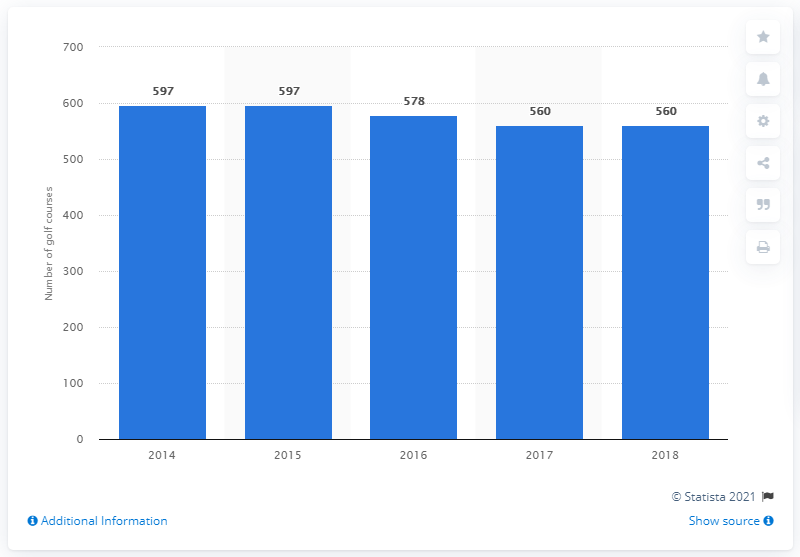Can you give me more information about the golfing history in Scotland? Certainly! Scotland is widely considered the birthplace of golf, with the game's early origins tracing back to the 15th century. The Old Course at St. Andrews, opened in 1552, is often referred to as 'the home of golf' and has played a pivotal role in the sport's development and popularity. 